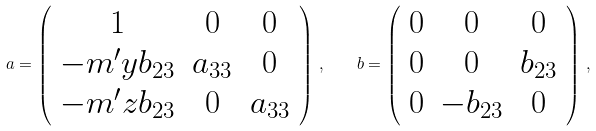<formula> <loc_0><loc_0><loc_500><loc_500>a = \left ( \begin{array} { c c c } 1 & 0 & 0 \\ - m ^ { \prime } y b _ { 2 3 } & a _ { 3 3 } & 0 \\ - m ^ { \prime } z b _ { 2 3 } & 0 & a _ { 3 3 } \end{array} \right ) \, , \quad b = \left ( \begin{array} { c c c } 0 & 0 & 0 \\ 0 & 0 & b _ { 2 3 } \\ 0 & - b _ { 2 3 } & 0 \end{array} \right ) \, ,</formula> 